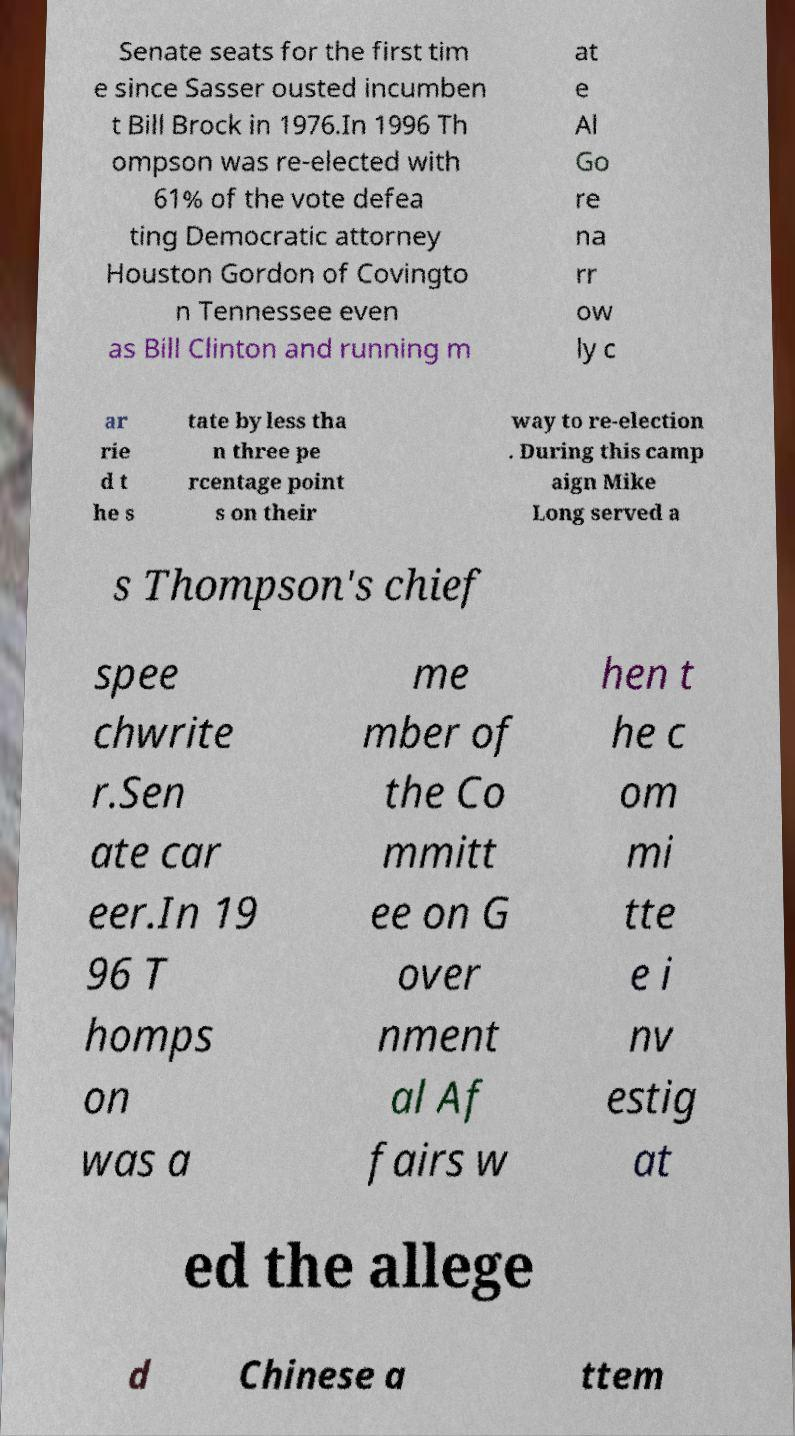For documentation purposes, I need the text within this image transcribed. Could you provide that? Senate seats for the first tim e since Sasser ousted incumben t Bill Brock in 1976.In 1996 Th ompson was re-elected with 61% of the vote defea ting Democratic attorney Houston Gordon of Covingto n Tennessee even as Bill Clinton and running m at e Al Go re na rr ow ly c ar rie d t he s tate by less tha n three pe rcentage point s on their way to re-election . During this camp aign Mike Long served a s Thompson's chief spee chwrite r.Sen ate car eer.In 19 96 T homps on was a me mber of the Co mmitt ee on G over nment al Af fairs w hen t he c om mi tte e i nv estig at ed the allege d Chinese a ttem 